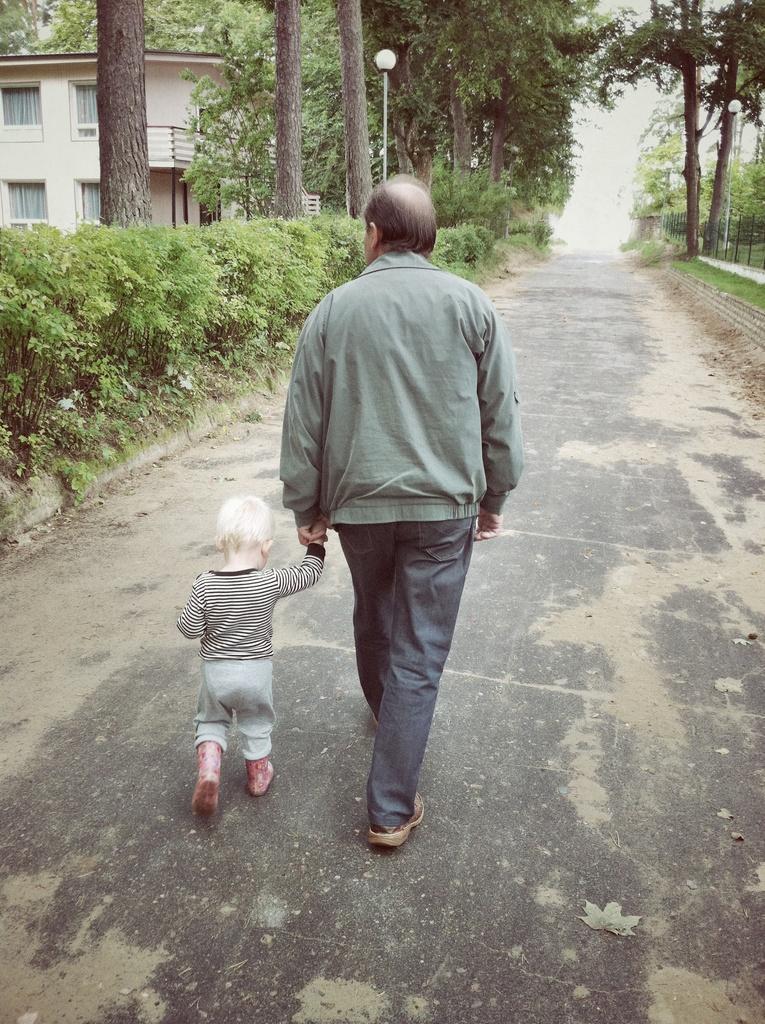In one or two sentences, can you explain what this image depicts? In this image there is a man walking along with boy beside him there are plants, trees and building. 